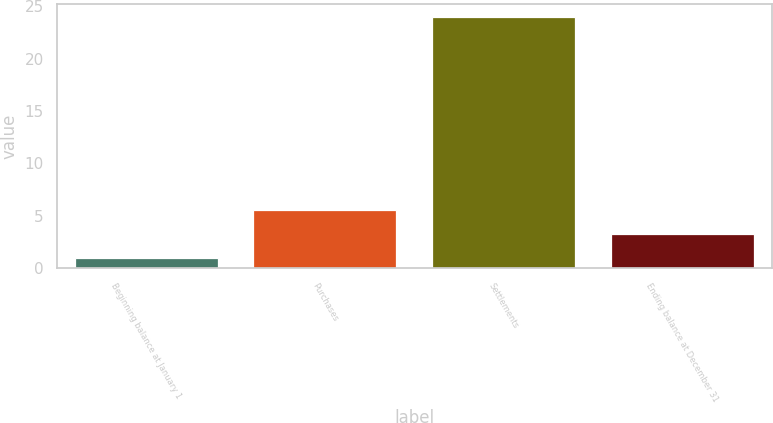Convert chart. <chart><loc_0><loc_0><loc_500><loc_500><bar_chart><fcel>Beginning balance at January 1<fcel>Purchases<fcel>Settlements<fcel>Ending balance at December 31<nl><fcel>1<fcel>5.6<fcel>24<fcel>3.3<nl></chart> 